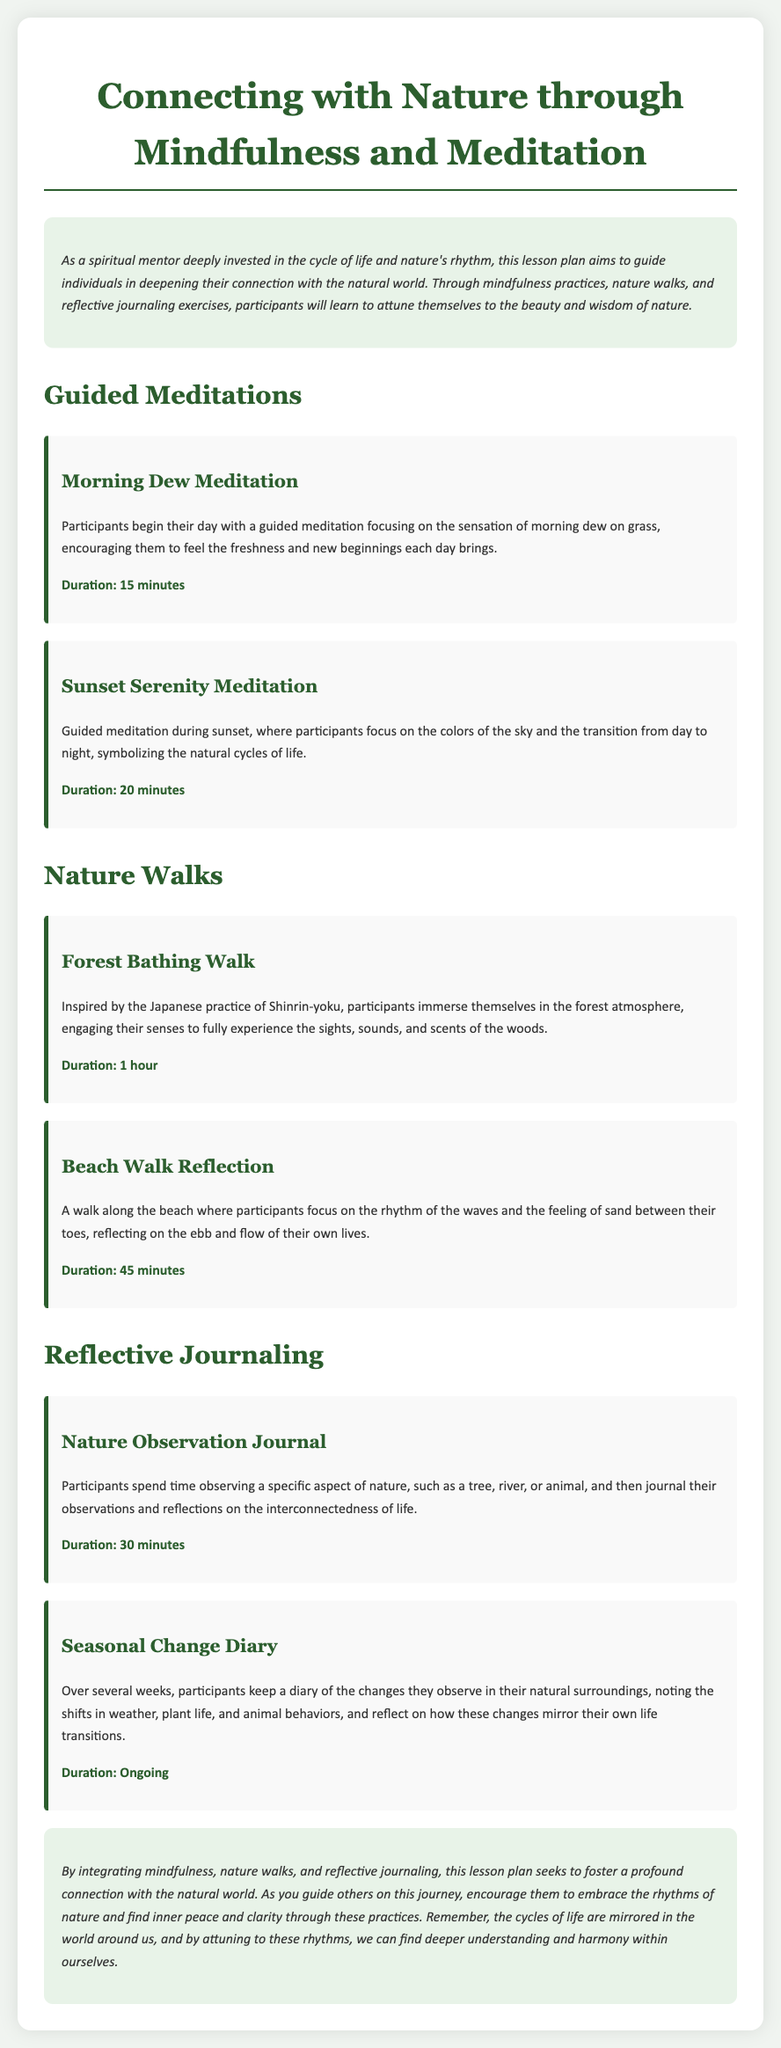What is the title of the lesson plan? The title of the lesson plan is indicated at the top of the document.
Answer: Connecting with Nature through Mindfulness and Meditation What is the duration of the Morning Dew Meditation? The duration is mentioned in the activity section related to Morning Dew Meditation.
Answer: 15 minutes What practice is inspired by the Japanese Shinrin-yoku? This refers to a specific nature walk activity described in the document.
Answer: Forest Bathing Walk How long is the Beach Walk Reflection? The duration is found in the Beach Walk Reflection activity description.
Answer: 45 minutes How often should participants keep the Seasonal Change Diary? This is inferred from the ongoing nature of the activity mentioned in the document.
Answer: Ongoing Why does the Sunset Serenity Meditation focus on the sky colors? This reasoning is based on the symbolism of natural cycles mentioned in the meditation description.
Answer: Natural cycles of life What is included in the reflective journaling exercises? The specific type of journaling is detailed in the Reflective Journaling section of the document.
Answer: Nature Observation Journal What is the main goal of the lesson plan? The goal is outlined in the introduction of the document explaining the connection with the natural world.
Answer: Foster a profound connection What is the theme of the conclusion? The conclusion summarizes the overall message of the lesson plan, which relates to nature.
Answer: Cycles of life are mirrored in nature 